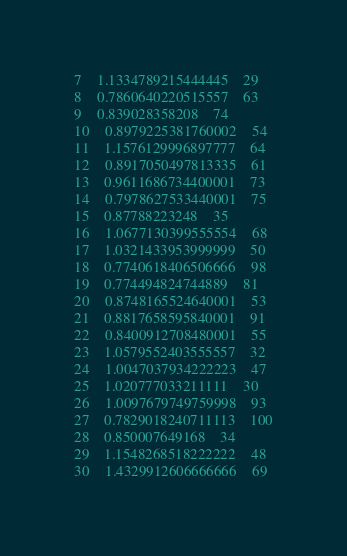<code> <loc_0><loc_0><loc_500><loc_500><_Rust_>7	1.1334789215444445	29
8	0.7860640220515557	63
9	0.839028358208	74
10	0.8979225381760002	54
11	1.1576129996897777	64
12	0.8917050497813335	61
13	0.9611686734400001	73
14	0.7978627533440001	75
15	0.87788223248	35
16	1.0677130399555554	68
17	1.0321433953999999	50
18	0.7740618406506666	98
19	0.774494824744889	81
20	0.8748165524640001	53
21	0.8817658595840001	91
22	0.8400912708480001	55
23	1.0579552403555557	32
24	1.0047037934222223	47
25	1.020777033211111	30
26	1.0097679749759998	93
27	0.7829018240711113	100
28	0.850007649168	34
29	1.1548268518222222	48
30	1.4329912606666666	69
</code> 